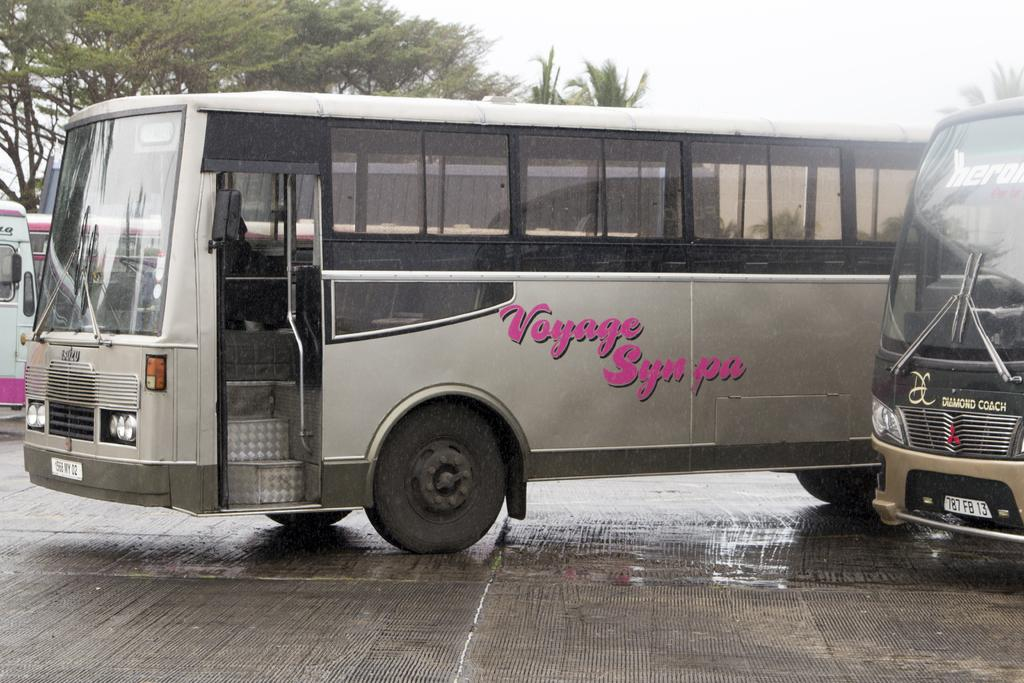What type of vehicles are present in the image? There are buses in the image. What can be seen in the background of the image? There are trees and the sky visible in the background of the image. What type of blood is visible on the paper in the image? There is no paper or blood present in the image; it features buses and a background with trees and the sky. 